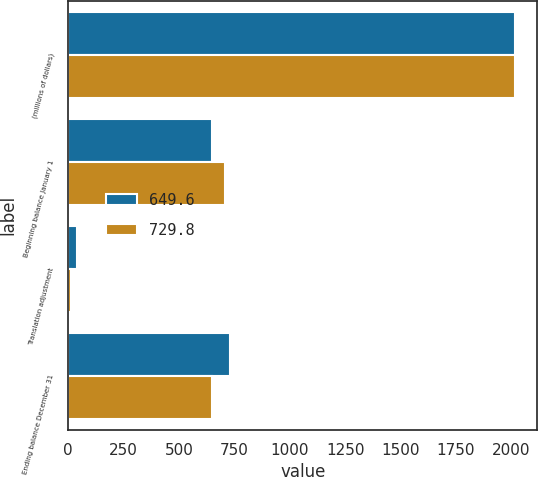<chart> <loc_0><loc_0><loc_500><loc_500><stacked_bar_chart><ecel><fcel>(millions of dollars)<fcel>Beginning balance January 1<fcel>Translation adjustment<fcel>Ending balance December 31<nl><fcel>649.6<fcel>2017<fcel>649.6<fcel>40.3<fcel>729.8<nl><fcel>729.8<fcel>2016<fcel>705.3<fcel>11.9<fcel>649.6<nl></chart> 